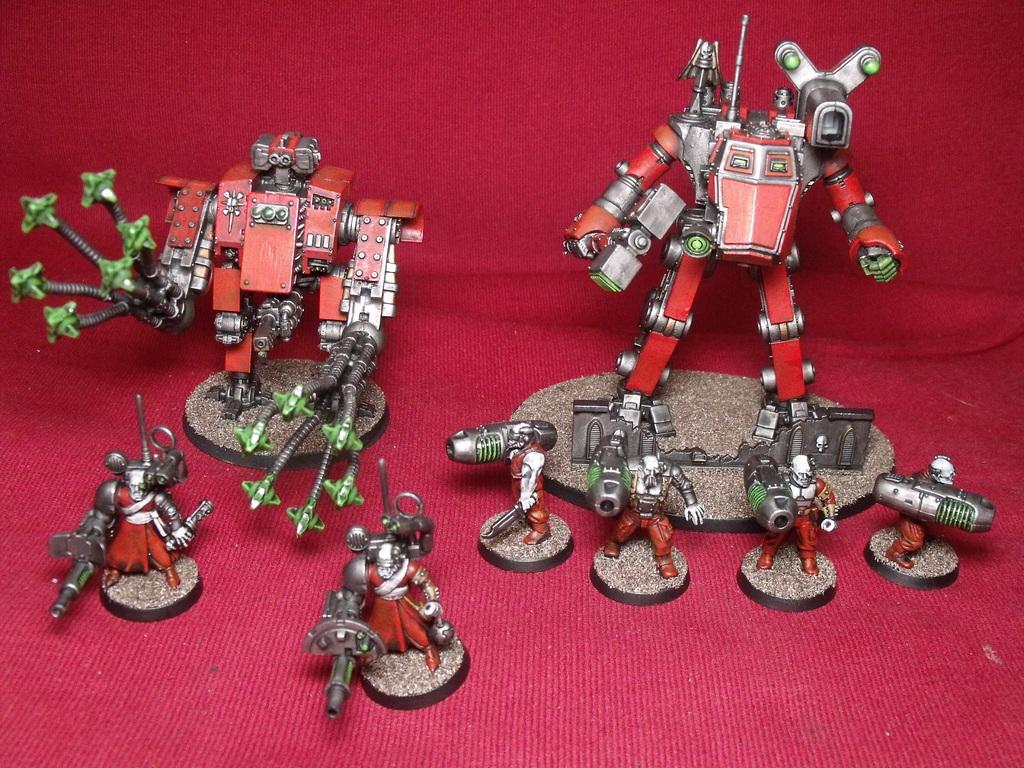What is the main subject of the image? The main subject of the image is a metal scrap. What can be seen in the background of the image? There is a red carpet in the background of the image. What effect does the band have on the metal scrap in the image? There is no band present in the image, so no effect can be observed on the metal scrap. 